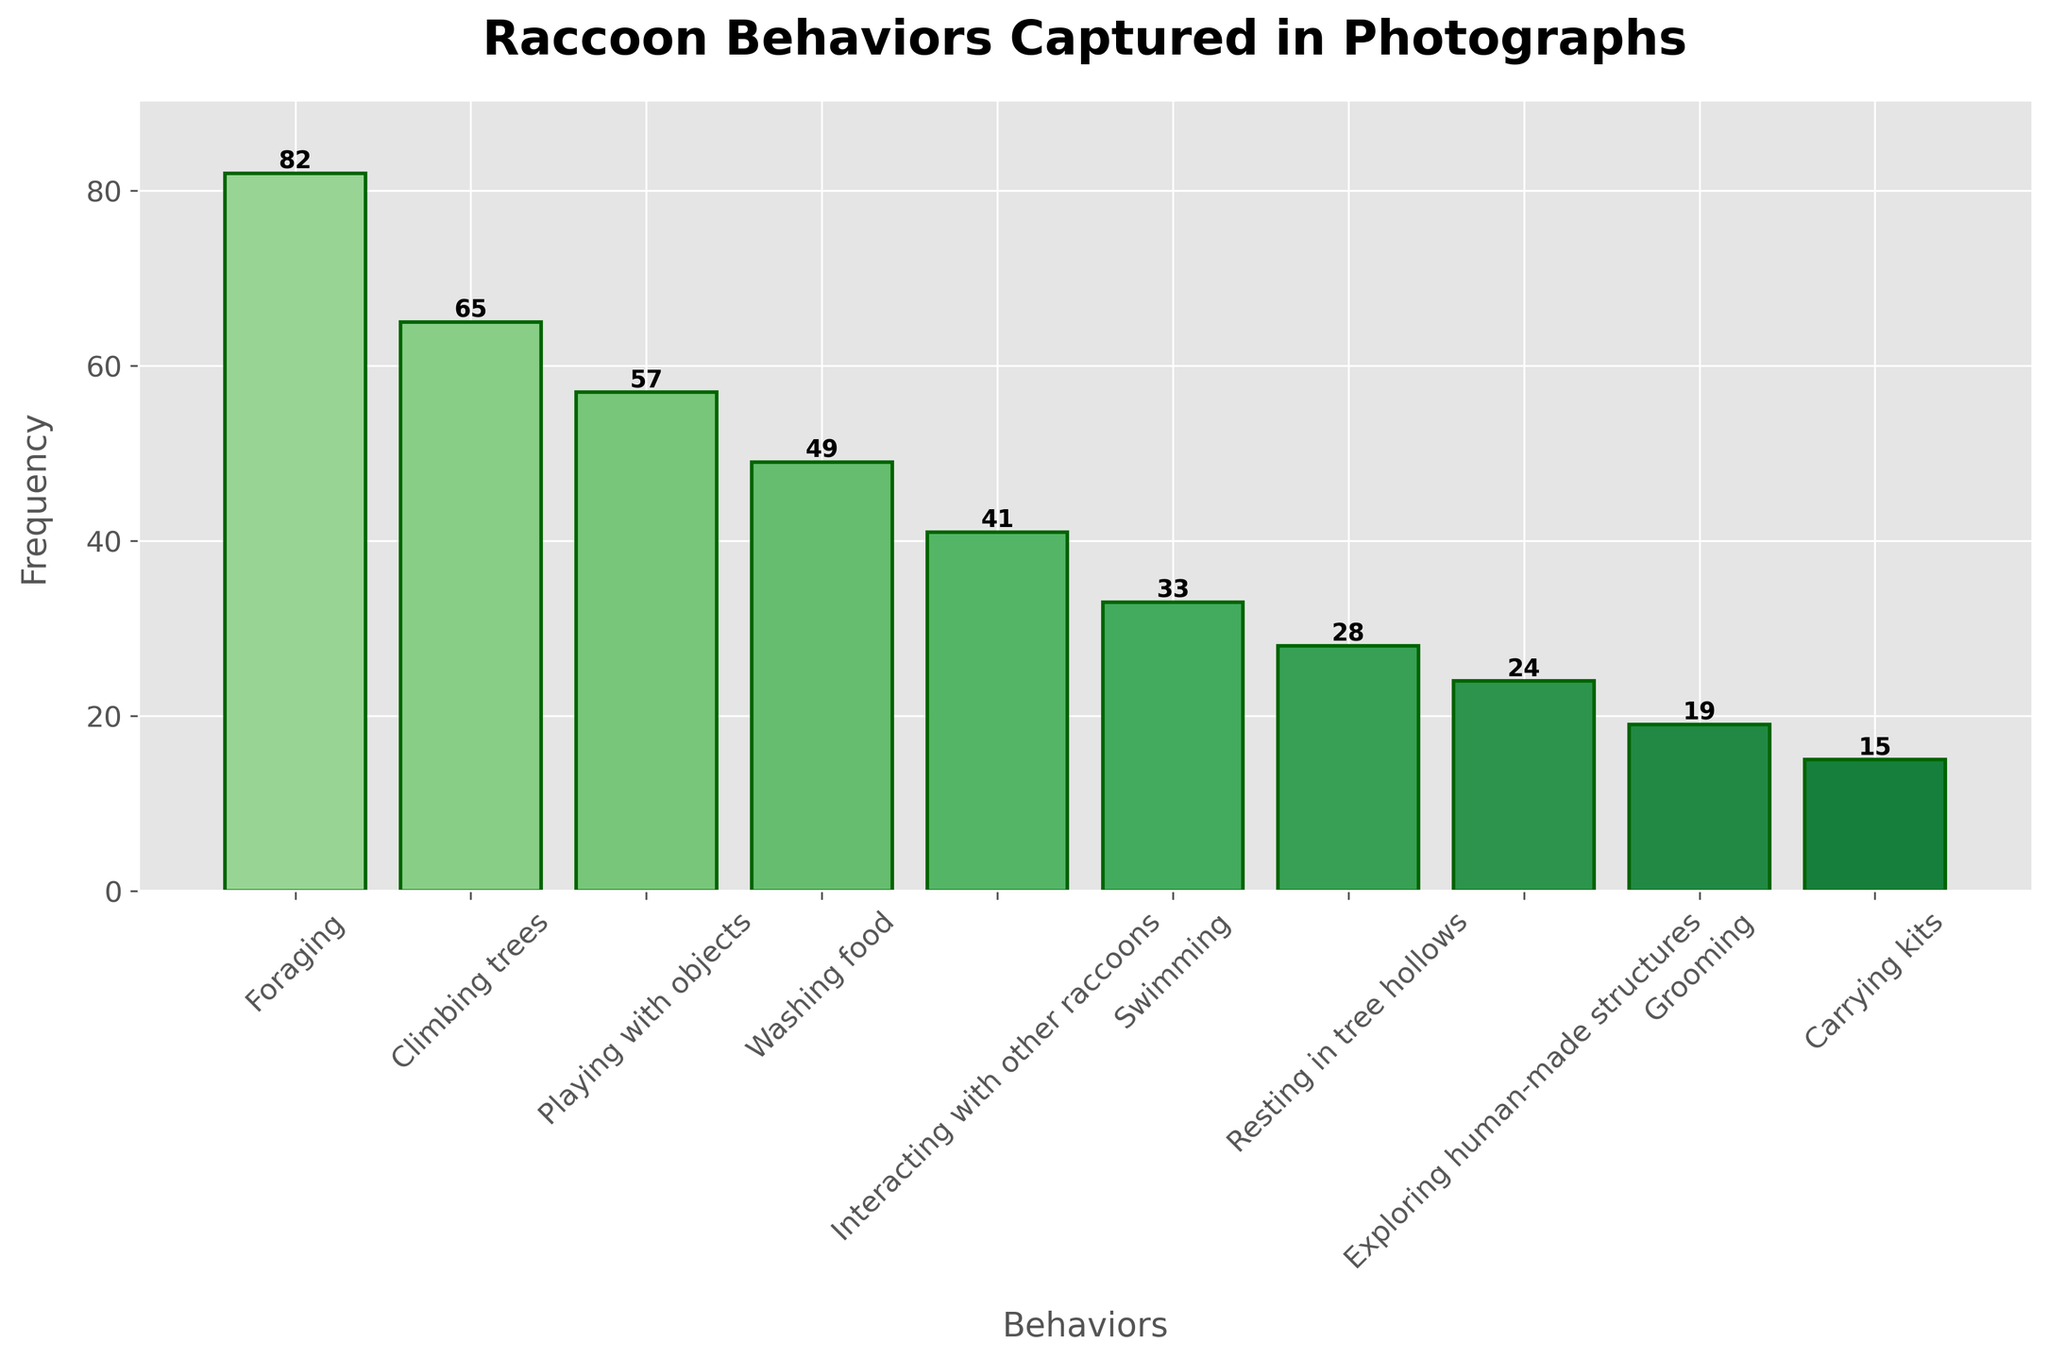What is the most common behavior exhibited by raccoons in the photographs? The figure shows the frequency of various raccoon behaviors with bars. The tallest bar represents the most common behavior. By looking at the tallest bar, we see that "Foraging" has the highest frequency at 82.
Answer: Foraging How much more frequent is "Playing with objects" compared to "Carrying kits"? To find this, we subtract the frequency of "Carrying kits" from "Playing with objects". "Playing with objects" is 57 and "Carrying kits" is 15, so 57 - 15 = 42.
Answer: 42 What are the total frequencies for the top three raccoon behaviors combined? The top three behaviors are "Foraging" (82), "Climbing trees" (65), and "Playing with objects" (57). Summing these values: 82 + 65 + 57 = 204.
Answer: 204 Which behavior has exactly half the frequency of "Foraging"? Half the frequency of "Foraging" (82) is 82 / 2 = 41. The behavior with a frequency of 41 is "Interacting with other raccoons".
Answer: Interacting with other raccoons Are there more instances of "Washing food" or "Swimming"? From the figure, "Washing food" has a frequency of 49 and "Swimming" has a frequency of 33. Since 49 > 33, there are more instances of "Washing food".
Answer: Washing food What is the difference in frequency between "Climbing trees" and "Exploring human-made structures"? We subtract the frequency of "Exploring human-made structures" from "Climbing trees". "Climbing trees" is 65 and "Exploring human-made structures" is 24, so 65 - 24 = 41.
Answer: 41 What is the average frequency of the behaviors "Resting in tree hollows," "Grooming," and "Carrying kits"? To find the average, sum the frequencies of these behaviors and divide by 3. Frequencies are 28, 19, and 15 respectively. (28 + 19 + 15) / 3 = 62 / 3 = 20.67 (rounded to two decimal places).
Answer: 20.67 Which behavior has the shortest bar, and what is its frequency? The shortest bar represents the least frequent behavior. From the figure, "Carrying kits" has the shortest bar with a frequency of 15.
Answer: Carrying kits, 15 